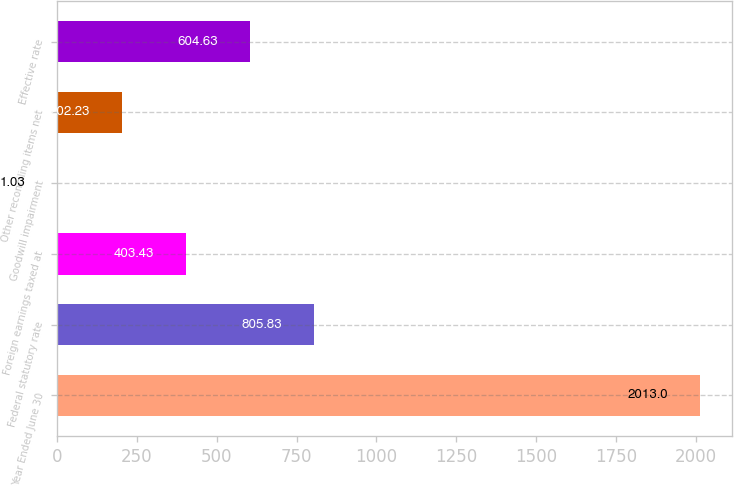Convert chart to OTSL. <chart><loc_0><loc_0><loc_500><loc_500><bar_chart><fcel>Year Ended June 30<fcel>Federal statutory rate<fcel>Foreign earnings taxed at<fcel>Goodwill impairment<fcel>Other reconciling items net<fcel>Effective rate<nl><fcel>2013<fcel>805.83<fcel>403.43<fcel>1.03<fcel>202.23<fcel>604.63<nl></chart> 